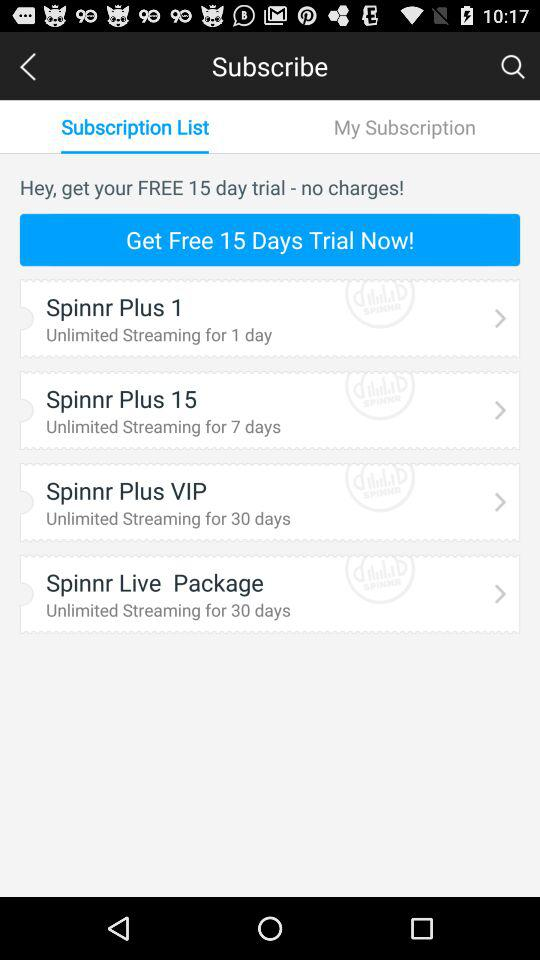What is the name of the plan that provides unlimited streaming for 7 days? The name of the plan is Spinnr Plus 15. 